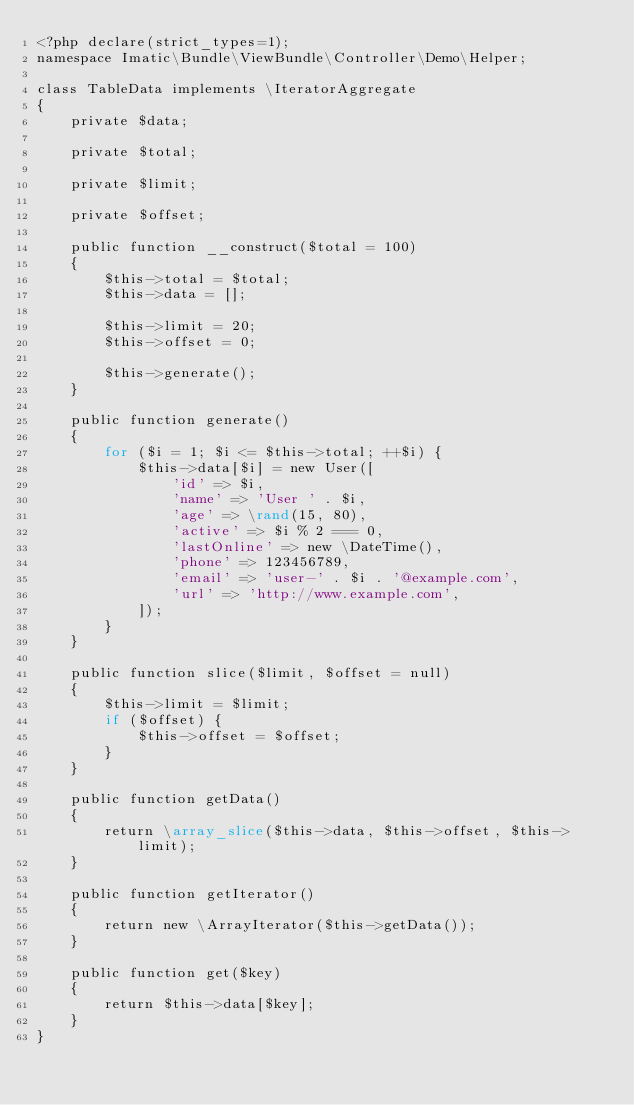Convert code to text. <code><loc_0><loc_0><loc_500><loc_500><_PHP_><?php declare(strict_types=1);
namespace Imatic\Bundle\ViewBundle\Controller\Demo\Helper;

class TableData implements \IteratorAggregate
{
    private $data;

    private $total;

    private $limit;

    private $offset;

    public function __construct($total = 100)
    {
        $this->total = $total;
        $this->data = [];

        $this->limit = 20;
        $this->offset = 0;

        $this->generate();
    }

    public function generate()
    {
        for ($i = 1; $i <= $this->total; ++$i) {
            $this->data[$i] = new User([
                'id' => $i,
                'name' => 'User ' . $i,
                'age' => \rand(15, 80),
                'active' => $i % 2 === 0,
                'lastOnline' => new \DateTime(),
                'phone' => 123456789,
                'email' => 'user-' . $i . '@example.com',
                'url' => 'http://www.example.com',
            ]);
        }
    }

    public function slice($limit, $offset = null)
    {
        $this->limit = $limit;
        if ($offset) {
            $this->offset = $offset;
        }
    }

    public function getData()
    {
        return \array_slice($this->data, $this->offset, $this->limit);
    }

    public function getIterator()
    {
        return new \ArrayIterator($this->getData());
    }

    public function get($key)
    {
        return $this->data[$key];
    }
}
</code> 